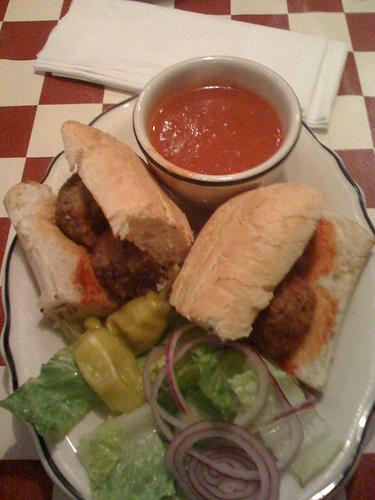What is the vegetable on this plate?
Be succinct. Lettuce. What color is the tablecloth?
Answer briefly. Red and white. Could that can contain soda?
Write a very short answer. No. Does this plate have bread?
Keep it brief. Yes. What is inside of this sandwich?
Give a very brief answer. Meatballs. Is this a sandwich for one?
Be succinct. Yes. What color is the counter?
Write a very short answer. Red and white. Is this a paper plate?
Give a very brief answer. No. What type of pepper is on the plate?
Write a very short answer. Pepperoncini. What is the green vegetable on the plate?
Keep it brief. Lettuce. Is there pasta in the bowl?
Write a very short answer. No. Is this a quiche?
Concise answer only. No. Is this a roast beef sandwich?
Give a very brief answer. No. What is next to the sandwich?
Answer briefly. Toppings. What color is the napkin?
Answer briefly. White. What type of design is on the plate?
Quick response, please. Stripe. What material is the plate made of?
Give a very brief answer. Ceramic. Did a man or a woman order this lunch?
Answer briefly. Man. Is there a fork in the photo?
Give a very brief answer. No. What's the main course of this meal?
Answer briefly. Sandwich. What are the ingredients inside this sandwich?
Write a very short answer. Meatballs. What is the bowl sitting on?
Give a very brief answer. Table. What do we call this lineup of food?
Keep it brief. Lunch. 